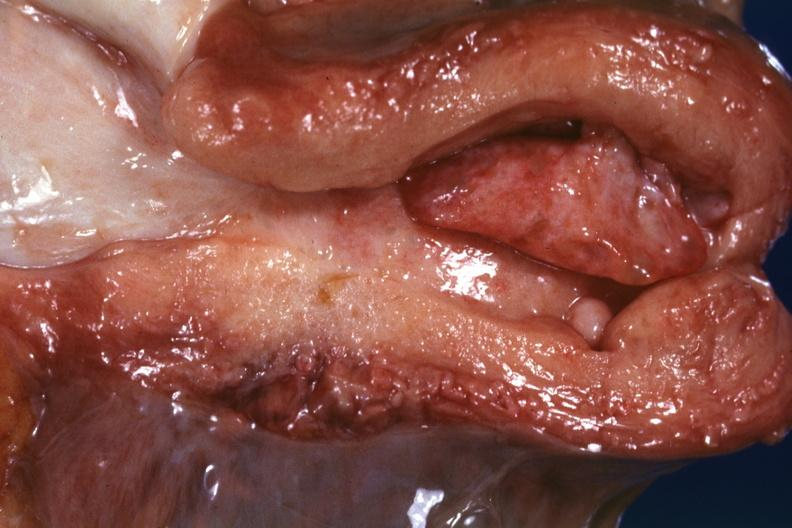does this image show large endometrial polyp probably senile type?
Answer the question using a single word or phrase. Yes 